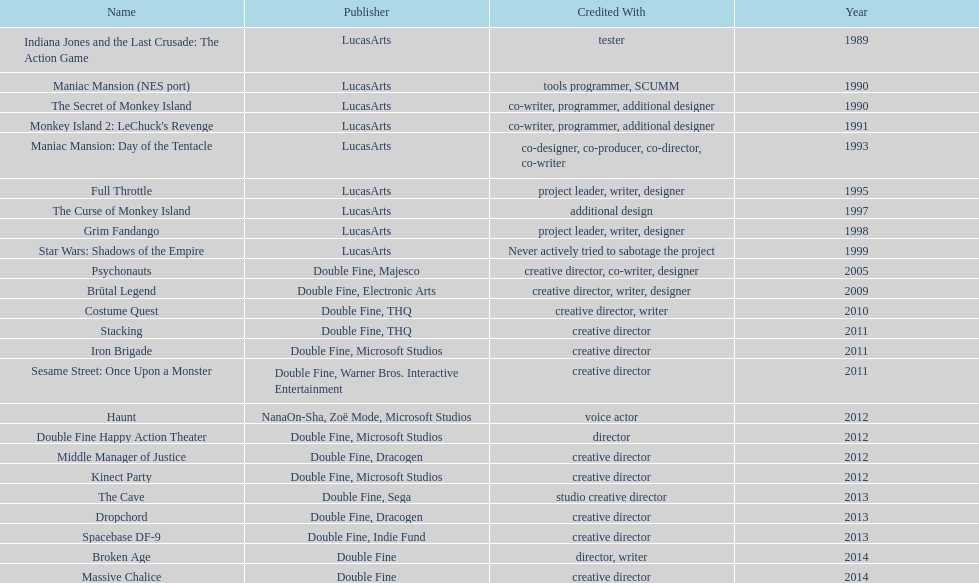How many games were credited with a creative director? 11. 